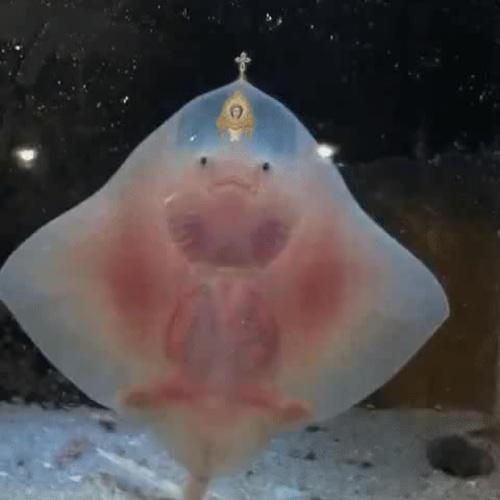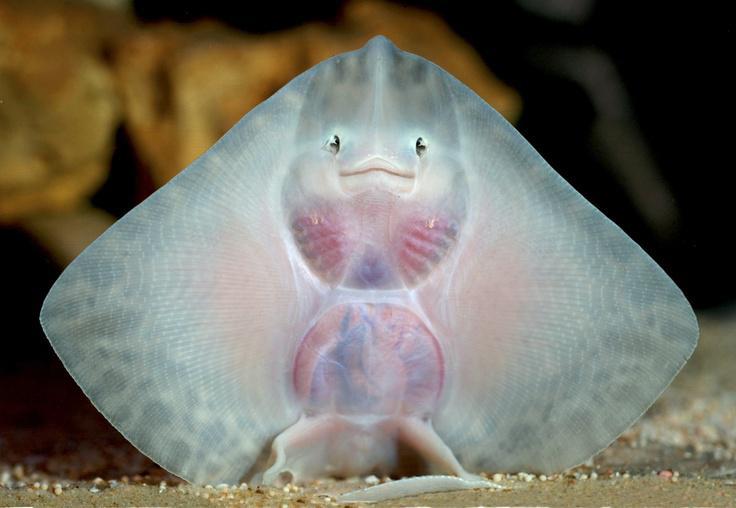The first image is the image on the left, the second image is the image on the right. Given the left and right images, does the statement "All of the stingrays are shown upright with undersides facing the camera and 'wings' outspread." hold true? Answer yes or no. Yes. The first image is the image on the left, the second image is the image on the right. Evaluate the accuracy of this statement regarding the images: "A single ray presses its body against the glass in each of the images.". Is it true? Answer yes or no. Yes. 